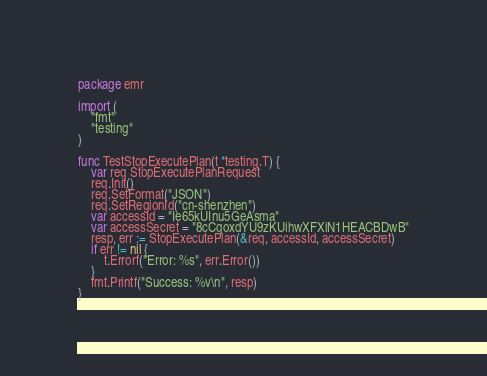Convert code to text. <code><loc_0><loc_0><loc_500><loc_500><_Go_>package emr

import (
	"fmt"
	"testing"
)

func TestStopExecutePlan(t *testing.T) {
	var req StopExecutePlanRequest
	req.Init()
	req.SetFormat("JSON")
	req.SetRegionId("cn-shenzhen")
	var accessId = "Ie65kUInu5GeAsma"
	var accessSecret = "8cCqoxdYU9zKUihwXFXiN1HEACBDwB"
	resp, err := StopExecutePlan(&req, accessId, accessSecret)
	if err != nil {
		t.Errorf("Error: %s", err.Error())
	}
	fmt.Printf("Success: %v\n", resp)
}
</code> 